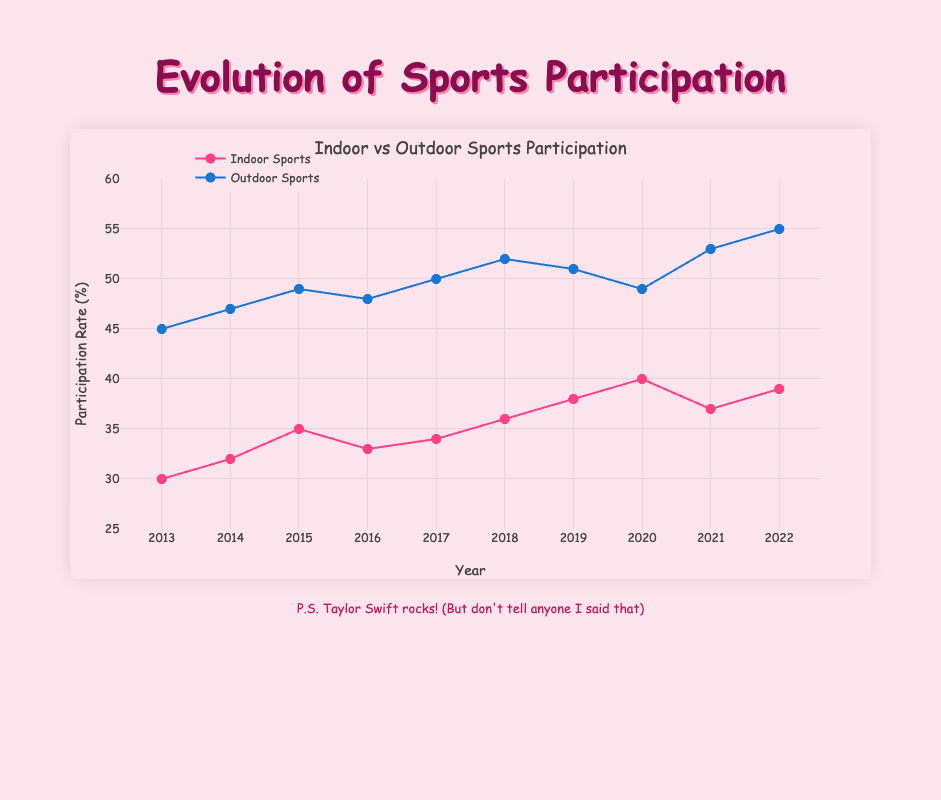What is the title of the chart? The title of the chart is prominently displayed at the top and reads "Indoor vs Outdoor Sports Participation".
Answer: Indoor vs Outdoor Sports Participation What color represents indoor sports participation? The indoor sports participation data points and trend line are represented in a pink shade. The markers and line are both pink.
Answer: Pink How many years of data are shown in the chart? The x-axis shows the years from 2013 to 2022, which includes a total of 10 years of data.
Answer: 10 Which year had the highest outdoor sports participation rate? To find the highest outdoor sports participation, locate the highest point on the outdoor (blue) trend line. The highest value appears in the year 2022.
Answer: 2022 Compare the participation rates of indoor and outdoor sports in 2015. Which was higher? In 2015, the indoor sports participation rate was 35%, while the outdoor sports participation rate was 49%. The outdoor rate was higher.
Answer: Outdoor What is the average participation rate for indoor sports between 2013 and 2022? Add all the indoor sports participation rates: (30 + 32 + 35 + 33 + 34 + 36 + 38 + 40 + 37 + 39) = 354, and then divide by the number of years, which is 10. The average is 354/10 = 35.4%.
Answer: 35.4% By how much did outdoor sports participation increase from 2013 to 2022? The outdoor sports participation rate in 2013 was 45%, and in 2022 it was 55%. The increase is 55% - 45% = 10%.
Answer: 10% In which year did indoor sports participation see a decrease compared to the previous year? Compare consecutive years on the indoor sports trend line. From 2015 to 2016, participation decreased from 35% to 33%.
Answer: 2016 What is the overall trend of outdoor sports participation over the decade? Increasing or decreasing? Visually follow the trend line for outdoor sports (blue). The overall direction from 2013 to 2022 is upward, indicating an increasing trend.
Answer: Increasing How did the indoor sports participation in 2017 compare to that in 2019? In 2017, indoor sports participation was 34%, and in 2019 it was 38%. Thus, the rate in 2019 was higher.
Answer: 2019 